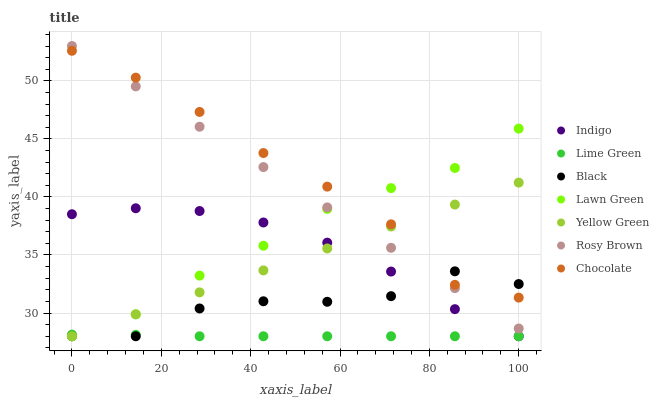Does Lime Green have the minimum area under the curve?
Answer yes or no. Yes. Does Chocolate have the maximum area under the curve?
Answer yes or no. Yes. Does Indigo have the minimum area under the curve?
Answer yes or no. No. Does Indigo have the maximum area under the curve?
Answer yes or no. No. Is Rosy Brown the smoothest?
Answer yes or no. Yes. Is Black the roughest?
Answer yes or no. Yes. Is Indigo the smoothest?
Answer yes or no. No. Is Indigo the roughest?
Answer yes or no. No. Does Lawn Green have the lowest value?
Answer yes or no. Yes. Does Rosy Brown have the lowest value?
Answer yes or no. No. Does Rosy Brown have the highest value?
Answer yes or no. Yes. Does Indigo have the highest value?
Answer yes or no. No. Is Indigo less than Chocolate?
Answer yes or no. Yes. Is Rosy Brown greater than Lime Green?
Answer yes or no. Yes. Does Lime Green intersect Yellow Green?
Answer yes or no. Yes. Is Lime Green less than Yellow Green?
Answer yes or no. No. Is Lime Green greater than Yellow Green?
Answer yes or no. No. Does Indigo intersect Chocolate?
Answer yes or no. No. 